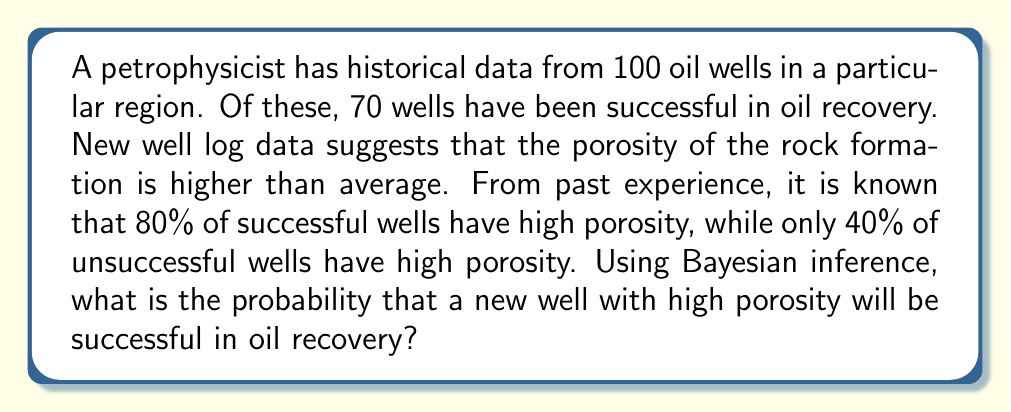Help me with this question. Let's approach this problem step-by-step using Bayesian inference:

1) Define our events:
   S: Successful oil recovery
   H: High porosity

2) Given information:
   P(S) = 70/100 = 0.7 (prior probability of success)
   P(H|S) = 0.8 (probability of high porosity given success)
   P(H|not S) = 0.4 (probability of high porosity given failure)

3) We want to find P(S|H) using Bayes' theorem:

   $$P(S|H) = \frac{P(H|S) \cdot P(S)}{P(H)}$$

4) We need to calculate P(H) using the law of total probability:

   $$P(H) = P(H|S) \cdot P(S) + P(H|not S) \cdot P(not S)$$
   $$P(H) = 0.8 \cdot 0.7 + 0.4 \cdot 0.3 = 0.56 + 0.12 = 0.68$$

5) Now we can apply Bayes' theorem:

   $$P(S|H) = \frac{0.8 \cdot 0.7}{0.68} = \frac{0.56}{0.68} \approx 0.8235$$

6) Converting to a percentage:

   0.8235 * 100% ≈ 82.35%

Therefore, the probability that a new well with high porosity will be successful in oil recovery is approximately 82.35%.
Answer: 82.35% 